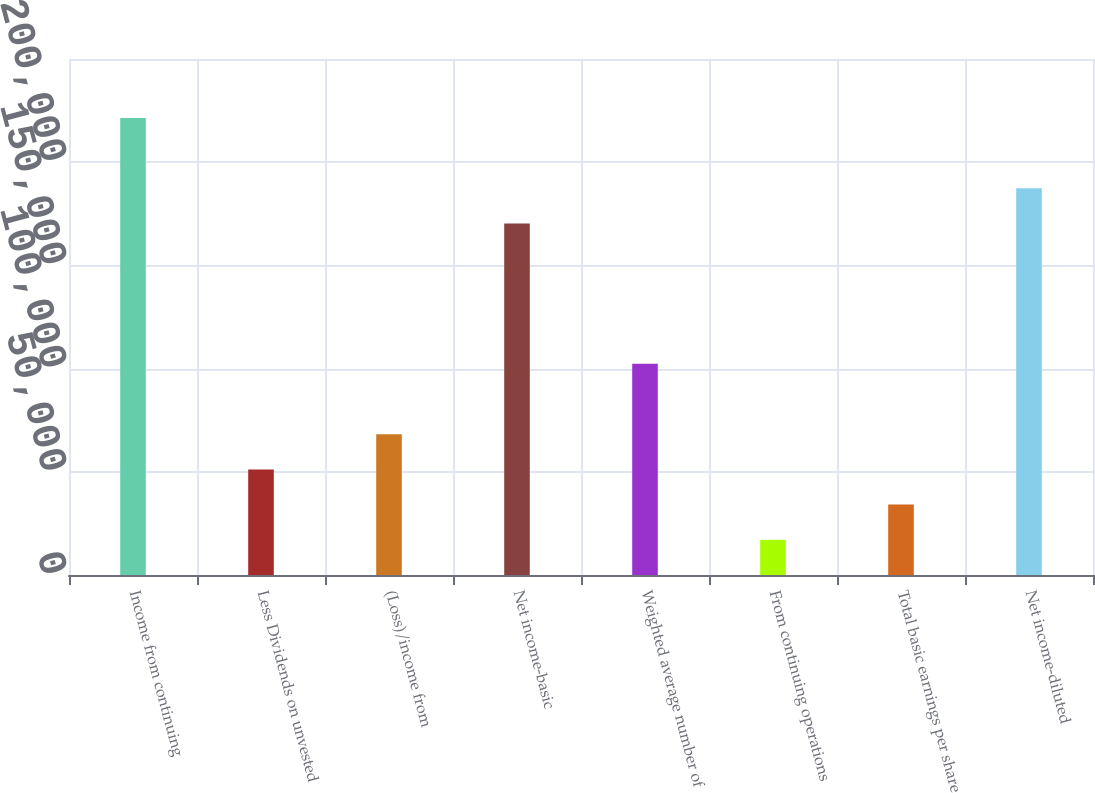Convert chart. <chart><loc_0><loc_0><loc_500><loc_500><bar_chart><fcel>Income from continuing<fcel>Less Dividends on unvested<fcel>(Loss)/income from<fcel>Net income-basic<fcel>Weighted average number of<fcel>From continuing operations<fcel>Total basic earnings per share<fcel>Net income-diluted<nl><fcel>221463<fcel>51157.9<fcel>68209.5<fcel>170308<fcel>102313<fcel>17054.8<fcel>34106.3<fcel>187360<nl></chart> 